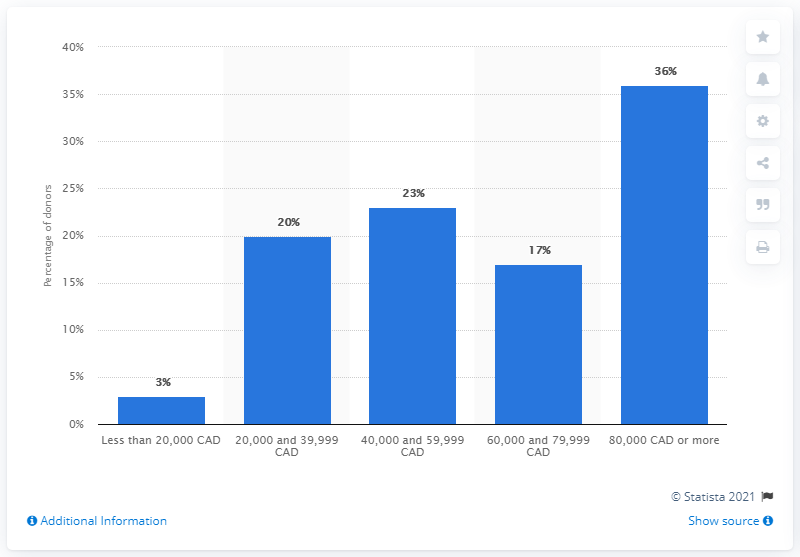Specify some key components in this picture. Of the total number of donors in Canada, 36% were individuals earning $80,000 or more. 